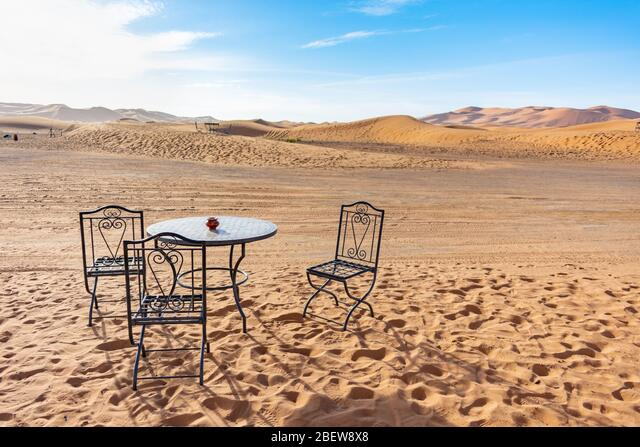How many chairs are there in the image? There are two wrought iron chairs positioned on the sand, creating a quaint and somewhat surreal seating arrangement in the vastness of the desert landscape. 